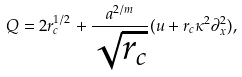<formula> <loc_0><loc_0><loc_500><loc_500>Q = 2 r _ { c } ^ { 1 / 2 } + \frac { a ^ { 2 / m } } { \sqrt { r _ { c } } } ( u + r _ { c } \kappa ^ { 2 } \partial ^ { 2 } _ { x } ) ,</formula> 